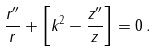Convert formula to latex. <formula><loc_0><loc_0><loc_500><loc_500>\frac { r ^ { \prime \prime } } { r } + \left [ k ^ { 2 } - \frac { z ^ { \prime \prime } } { z } \right ] = 0 \, .</formula> 